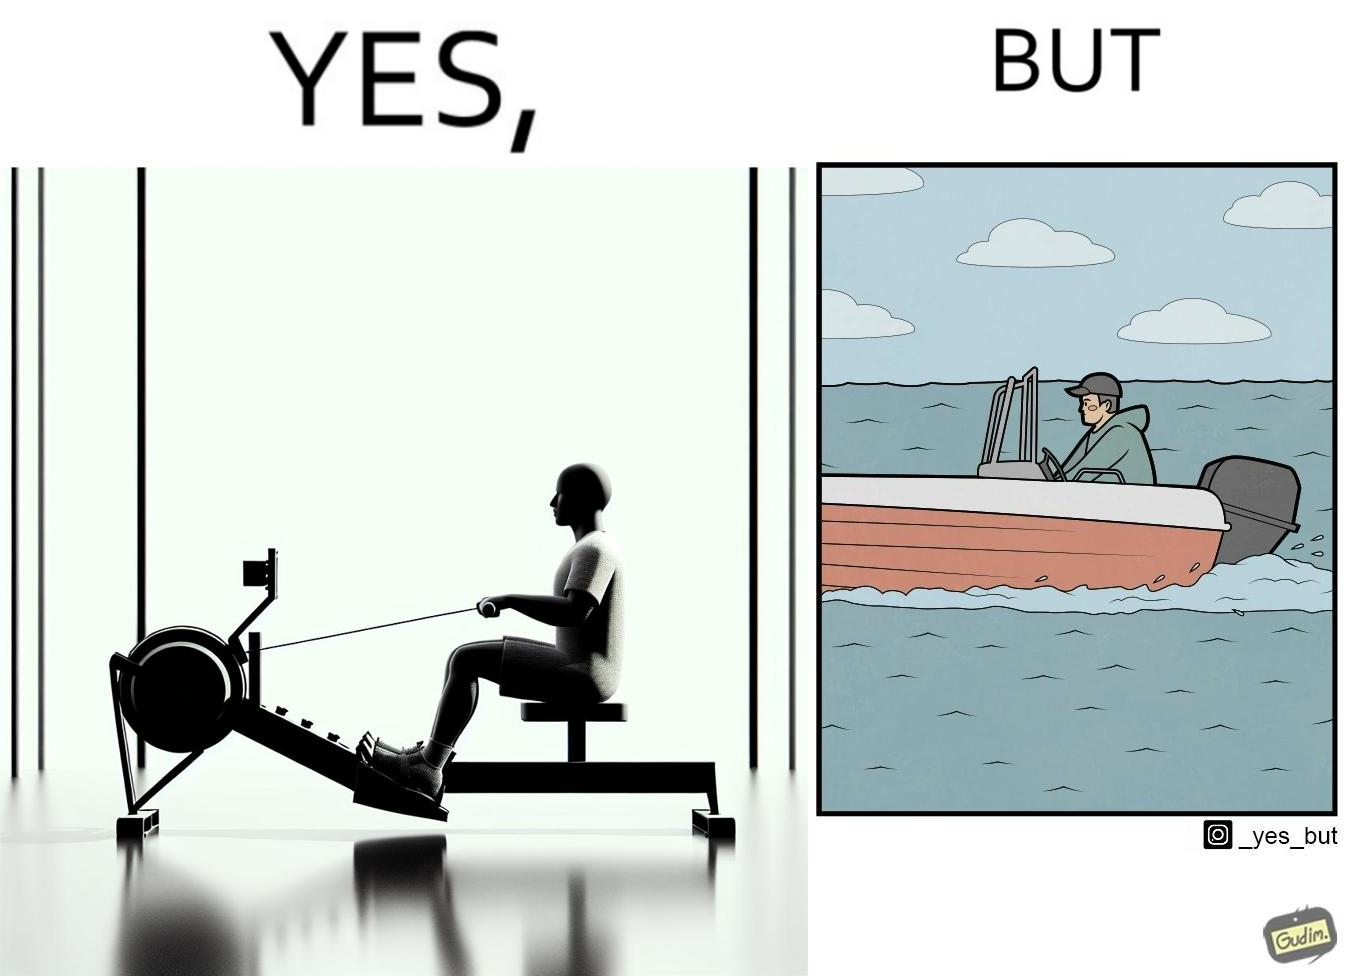Describe what you see in this image. The image is ironic, because people often use rowing machine at the gym don't prefer rowing when it comes to boats 